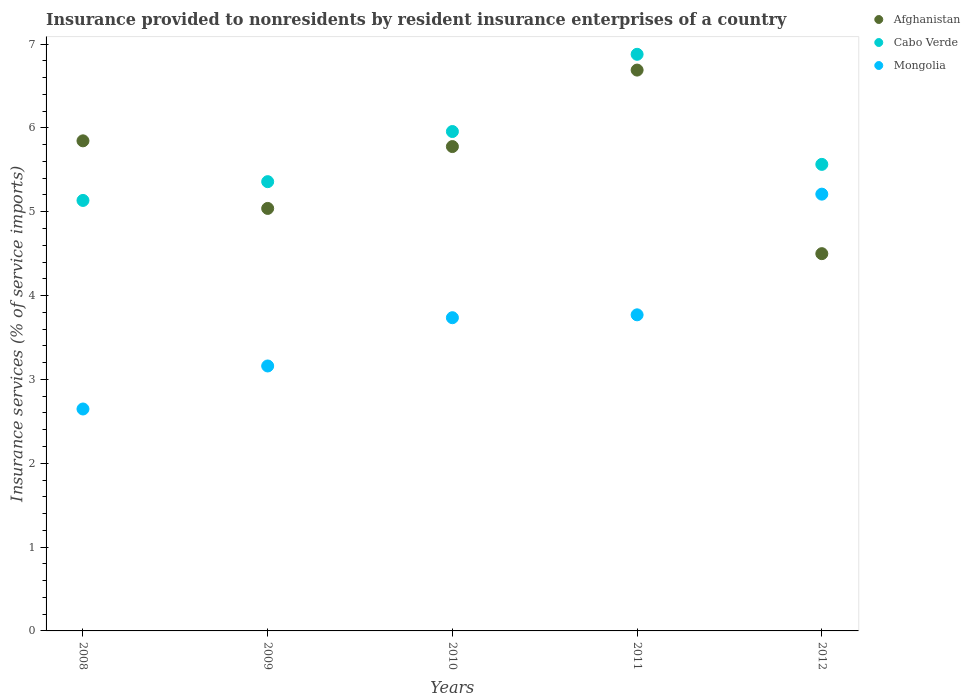What is the insurance provided to nonresidents in Afghanistan in 2010?
Provide a succinct answer. 5.78. Across all years, what is the maximum insurance provided to nonresidents in Afghanistan?
Ensure brevity in your answer.  6.69. Across all years, what is the minimum insurance provided to nonresidents in Mongolia?
Make the answer very short. 2.65. In which year was the insurance provided to nonresidents in Cabo Verde minimum?
Make the answer very short. 2008. What is the total insurance provided to nonresidents in Mongolia in the graph?
Keep it short and to the point. 18.52. What is the difference between the insurance provided to nonresidents in Cabo Verde in 2009 and that in 2012?
Provide a succinct answer. -0.21. What is the difference between the insurance provided to nonresidents in Afghanistan in 2011 and the insurance provided to nonresidents in Mongolia in 2009?
Ensure brevity in your answer.  3.53. What is the average insurance provided to nonresidents in Afghanistan per year?
Your answer should be compact. 5.57. In the year 2011, what is the difference between the insurance provided to nonresidents in Afghanistan and insurance provided to nonresidents in Mongolia?
Keep it short and to the point. 2.92. What is the ratio of the insurance provided to nonresidents in Cabo Verde in 2009 to that in 2010?
Provide a short and direct response. 0.9. Is the difference between the insurance provided to nonresidents in Afghanistan in 2009 and 2012 greater than the difference between the insurance provided to nonresidents in Mongolia in 2009 and 2012?
Offer a terse response. Yes. What is the difference between the highest and the second highest insurance provided to nonresidents in Mongolia?
Your answer should be very brief. 1.44. What is the difference between the highest and the lowest insurance provided to nonresidents in Mongolia?
Offer a terse response. 2.56. In how many years, is the insurance provided to nonresidents in Mongolia greater than the average insurance provided to nonresidents in Mongolia taken over all years?
Your answer should be very brief. 3. Is the sum of the insurance provided to nonresidents in Mongolia in 2010 and 2012 greater than the maximum insurance provided to nonresidents in Afghanistan across all years?
Your answer should be compact. Yes. Is it the case that in every year, the sum of the insurance provided to nonresidents in Afghanistan and insurance provided to nonresidents in Mongolia  is greater than the insurance provided to nonresidents in Cabo Verde?
Ensure brevity in your answer.  Yes. Is the insurance provided to nonresidents in Mongolia strictly less than the insurance provided to nonresidents in Afghanistan over the years?
Your answer should be very brief. No. What is the title of the graph?
Keep it short and to the point. Insurance provided to nonresidents by resident insurance enterprises of a country. Does "Tunisia" appear as one of the legend labels in the graph?
Keep it short and to the point. No. What is the label or title of the X-axis?
Provide a short and direct response. Years. What is the label or title of the Y-axis?
Offer a very short reply. Insurance services (% of service imports). What is the Insurance services (% of service imports) of Afghanistan in 2008?
Ensure brevity in your answer.  5.85. What is the Insurance services (% of service imports) of Cabo Verde in 2008?
Keep it short and to the point. 5.13. What is the Insurance services (% of service imports) of Mongolia in 2008?
Your answer should be very brief. 2.65. What is the Insurance services (% of service imports) of Afghanistan in 2009?
Provide a short and direct response. 5.04. What is the Insurance services (% of service imports) in Cabo Verde in 2009?
Keep it short and to the point. 5.36. What is the Insurance services (% of service imports) of Mongolia in 2009?
Offer a very short reply. 3.16. What is the Insurance services (% of service imports) of Afghanistan in 2010?
Your response must be concise. 5.78. What is the Insurance services (% of service imports) of Cabo Verde in 2010?
Your answer should be compact. 5.96. What is the Insurance services (% of service imports) of Mongolia in 2010?
Your answer should be very brief. 3.74. What is the Insurance services (% of service imports) of Afghanistan in 2011?
Your answer should be very brief. 6.69. What is the Insurance services (% of service imports) in Cabo Verde in 2011?
Provide a succinct answer. 6.88. What is the Insurance services (% of service imports) of Mongolia in 2011?
Offer a very short reply. 3.77. What is the Insurance services (% of service imports) of Afghanistan in 2012?
Your response must be concise. 4.5. What is the Insurance services (% of service imports) of Cabo Verde in 2012?
Offer a terse response. 5.56. What is the Insurance services (% of service imports) in Mongolia in 2012?
Make the answer very short. 5.21. Across all years, what is the maximum Insurance services (% of service imports) of Afghanistan?
Your answer should be very brief. 6.69. Across all years, what is the maximum Insurance services (% of service imports) in Cabo Verde?
Keep it short and to the point. 6.88. Across all years, what is the maximum Insurance services (% of service imports) in Mongolia?
Your answer should be compact. 5.21. Across all years, what is the minimum Insurance services (% of service imports) in Afghanistan?
Ensure brevity in your answer.  4.5. Across all years, what is the minimum Insurance services (% of service imports) of Cabo Verde?
Provide a succinct answer. 5.13. Across all years, what is the minimum Insurance services (% of service imports) of Mongolia?
Keep it short and to the point. 2.65. What is the total Insurance services (% of service imports) of Afghanistan in the graph?
Offer a very short reply. 27.85. What is the total Insurance services (% of service imports) in Cabo Verde in the graph?
Your answer should be very brief. 28.89. What is the total Insurance services (% of service imports) in Mongolia in the graph?
Provide a succinct answer. 18.52. What is the difference between the Insurance services (% of service imports) in Afghanistan in 2008 and that in 2009?
Your answer should be very brief. 0.81. What is the difference between the Insurance services (% of service imports) in Cabo Verde in 2008 and that in 2009?
Offer a terse response. -0.22. What is the difference between the Insurance services (% of service imports) of Mongolia in 2008 and that in 2009?
Your answer should be very brief. -0.51. What is the difference between the Insurance services (% of service imports) of Afghanistan in 2008 and that in 2010?
Give a very brief answer. 0.07. What is the difference between the Insurance services (% of service imports) in Cabo Verde in 2008 and that in 2010?
Ensure brevity in your answer.  -0.82. What is the difference between the Insurance services (% of service imports) of Mongolia in 2008 and that in 2010?
Keep it short and to the point. -1.09. What is the difference between the Insurance services (% of service imports) of Afghanistan in 2008 and that in 2011?
Your answer should be compact. -0.84. What is the difference between the Insurance services (% of service imports) of Cabo Verde in 2008 and that in 2011?
Your answer should be compact. -1.74. What is the difference between the Insurance services (% of service imports) of Mongolia in 2008 and that in 2011?
Ensure brevity in your answer.  -1.12. What is the difference between the Insurance services (% of service imports) in Afghanistan in 2008 and that in 2012?
Offer a terse response. 1.35. What is the difference between the Insurance services (% of service imports) of Cabo Verde in 2008 and that in 2012?
Make the answer very short. -0.43. What is the difference between the Insurance services (% of service imports) in Mongolia in 2008 and that in 2012?
Your answer should be compact. -2.56. What is the difference between the Insurance services (% of service imports) in Afghanistan in 2009 and that in 2010?
Give a very brief answer. -0.74. What is the difference between the Insurance services (% of service imports) of Cabo Verde in 2009 and that in 2010?
Offer a terse response. -0.6. What is the difference between the Insurance services (% of service imports) of Mongolia in 2009 and that in 2010?
Offer a very short reply. -0.58. What is the difference between the Insurance services (% of service imports) of Afghanistan in 2009 and that in 2011?
Your answer should be compact. -1.65. What is the difference between the Insurance services (% of service imports) in Cabo Verde in 2009 and that in 2011?
Your answer should be compact. -1.52. What is the difference between the Insurance services (% of service imports) in Mongolia in 2009 and that in 2011?
Offer a terse response. -0.61. What is the difference between the Insurance services (% of service imports) of Afghanistan in 2009 and that in 2012?
Provide a short and direct response. 0.54. What is the difference between the Insurance services (% of service imports) of Cabo Verde in 2009 and that in 2012?
Offer a very short reply. -0.21. What is the difference between the Insurance services (% of service imports) of Mongolia in 2009 and that in 2012?
Offer a terse response. -2.05. What is the difference between the Insurance services (% of service imports) of Afghanistan in 2010 and that in 2011?
Offer a terse response. -0.91. What is the difference between the Insurance services (% of service imports) of Cabo Verde in 2010 and that in 2011?
Give a very brief answer. -0.92. What is the difference between the Insurance services (% of service imports) in Mongolia in 2010 and that in 2011?
Provide a succinct answer. -0.03. What is the difference between the Insurance services (% of service imports) in Afghanistan in 2010 and that in 2012?
Make the answer very short. 1.28. What is the difference between the Insurance services (% of service imports) in Cabo Verde in 2010 and that in 2012?
Make the answer very short. 0.39. What is the difference between the Insurance services (% of service imports) of Mongolia in 2010 and that in 2012?
Your response must be concise. -1.47. What is the difference between the Insurance services (% of service imports) in Afghanistan in 2011 and that in 2012?
Provide a succinct answer. 2.19. What is the difference between the Insurance services (% of service imports) of Cabo Verde in 2011 and that in 2012?
Your response must be concise. 1.31. What is the difference between the Insurance services (% of service imports) in Mongolia in 2011 and that in 2012?
Make the answer very short. -1.44. What is the difference between the Insurance services (% of service imports) of Afghanistan in 2008 and the Insurance services (% of service imports) of Cabo Verde in 2009?
Offer a very short reply. 0.49. What is the difference between the Insurance services (% of service imports) in Afghanistan in 2008 and the Insurance services (% of service imports) in Mongolia in 2009?
Your response must be concise. 2.69. What is the difference between the Insurance services (% of service imports) of Cabo Verde in 2008 and the Insurance services (% of service imports) of Mongolia in 2009?
Provide a succinct answer. 1.97. What is the difference between the Insurance services (% of service imports) in Afghanistan in 2008 and the Insurance services (% of service imports) in Cabo Verde in 2010?
Make the answer very short. -0.11. What is the difference between the Insurance services (% of service imports) in Afghanistan in 2008 and the Insurance services (% of service imports) in Mongolia in 2010?
Your answer should be compact. 2.11. What is the difference between the Insurance services (% of service imports) of Cabo Verde in 2008 and the Insurance services (% of service imports) of Mongolia in 2010?
Your answer should be very brief. 1.4. What is the difference between the Insurance services (% of service imports) of Afghanistan in 2008 and the Insurance services (% of service imports) of Cabo Verde in 2011?
Keep it short and to the point. -1.03. What is the difference between the Insurance services (% of service imports) of Afghanistan in 2008 and the Insurance services (% of service imports) of Mongolia in 2011?
Your answer should be very brief. 2.08. What is the difference between the Insurance services (% of service imports) of Cabo Verde in 2008 and the Insurance services (% of service imports) of Mongolia in 2011?
Give a very brief answer. 1.36. What is the difference between the Insurance services (% of service imports) of Afghanistan in 2008 and the Insurance services (% of service imports) of Cabo Verde in 2012?
Offer a terse response. 0.28. What is the difference between the Insurance services (% of service imports) in Afghanistan in 2008 and the Insurance services (% of service imports) in Mongolia in 2012?
Offer a terse response. 0.64. What is the difference between the Insurance services (% of service imports) of Cabo Verde in 2008 and the Insurance services (% of service imports) of Mongolia in 2012?
Provide a succinct answer. -0.07. What is the difference between the Insurance services (% of service imports) in Afghanistan in 2009 and the Insurance services (% of service imports) in Cabo Verde in 2010?
Your response must be concise. -0.92. What is the difference between the Insurance services (% of service imports) of Afghanistan in 2009 and the Insurance services (% of service imports) of Mongolia in 2010?
Make the answer very short. 1.3. What is the difference between the Insurance services (% of service imports) of Cabo Verde in 2009 and the Insurance services (% of service imports) of Mongolia in 2010?
Your answer should be compact. 1.62. What is the difference between the Insurance services (% of service imports) of Afghanistan in 2009 and the Insurance services (% of service imports) of Cabo Verde in 2011?
Give a very brief answer. -1.84. What is the difference between the Insurance services (% of service imports) in Afghanistan in 2009 and the Insurance services (% of service imports) in Mongolia in 2011?
Your answer should be very brief. 1.27. What is the difference between the Insurance services (% of service imports) in Cabo Verde in 2009 and the Insurance services (% of service imports) in Mongolia in 2011?
Give a very brief answer. 1.59. What is the difference between the Insurance services (% of service imports) in Afghanistan in 2009 and the Insurance services (% of service imports) in Cabo Verde in 2012?
Provide a succinct answer. -0.53. What is the difference between the Insurance services (% of service imports) in Afghanistan in 2009 and the Insurance services (% of service imports) in Mongolia in 2012?
Your answer should be compact. -0.17. What is the difference between the Insurance services (% of service imports) in Cabo Verde in 2009 and the Insurance services (% of service imports) in Mongolia in 2012?
Your answer should be compact. 0.15. What is the difference between the Insurance services (% of service imports) of Afghanistan in 2010 and the Insurance services (% of service imports) of Cabo Verde in 2011?
Provide a short and direct response. -1.1. What is the difference between the Insurance services (% of service imports) of Afghanistan in 2010 and the Insurance services (% of service imports) of Mongolia in 2011?
Provide a short and direct response. 2.01. What is the difference between the Insurance services (% of service imports) of Cabo Verde in 2010 and the Insurance services (% of service imports) of Mongolia in 2011?
Your answer should be very brief. 2.19. What is the difference between the Insurance services (% of service imports) of Afghanistan in 2010 and the Insurance services (% of service imports) of Cabo Verde in 2012?
Give a very brief answer. 0.21. What is the difference between the Insurance services (% of service imports) of Afghanistan in 2010 and the Insurance services (% of service imports) of Mongolia in 2012?
Keep it short and to the point. 0.57. What is the difference between the Insurance services (% of service imports) in Cabo Verde in 2010 and the Insurance services (% of service imports) in Mongolia in 2012?
Your response must be concise. 0.75. What is the difference between the Insurance services (% of service imports) in Afghanistan in 2011 and the Insurance services (% of service imports) in Cabo Verde in 2012?
Make the answer very short. 1.12. What is the difference between the Insurance services (% of service imports) in Afghanistan in 2011 and the Insurance services (% of service imports) in Mongolia in 2012?
Your answer should be compact. 1.48. What is the difference between the Insurance services (% of service imports) in Cabo Verde in 2011 and the Insurance services (% of service imports) in Mongolia in 2012?
Provide a succinct answer. 1.67. What is the average Insurance services (% of service imports) in Afghanistan per year?
Your answer should be compact. 5.57. What is the average Insurance services (% of service imports) of Cabo Verde per year?
Ensure brevity in your answer.  5.78. What is the average Insurance services (% of service imports) of Mongolia per year?
Provide a short and direct response. 3.7. In the year 2008, what is the difference between the Insurance services (% of service imports) in Afghanistan and Insurance services (% of service imports) in Cabo Verde?
Offer a terse response. 0.71. In the year 2008, what is the difference between the Insurance services (% of service imports) in Afghanistan and Insurance services (% of service imports) in Mongolia?
Your answer should be very brief. 3.2. In the year 2008, what is the difference between the Insurance services (% of service imports) in Cabo Verde and Insurance services (% of service imports) in Mongolia?
Offer a terse response. 2.49. In the year 2009, what is the difference between the Insurance services (% of service imports) in Afghanistan and Insurance services (% of service imports) in Cabo Verde?
Ensure brevity in your answer.  -0.32. In the year 2009, what is the difference between the Insurance services (% of service imports) in Afghanistan and Insurance services (% of service imports) in Mongolia?
Offer a very short reply. 1.88. In the year 2009, what is the difference between the Insurance services (% of service imports) of Cabo Verde and Insurance services (% of service imports) of Mongolia?
Your response must be concise. 2.2. In the year 2010, what is the difference between the Insurance services (% of service imports) of Afghanistan and Insurance services (% of service imports) of Cabo Verde?
Provide a short and direct response. -0.18. In the year 2010, what is the difference between the Insurance services (% of service imports) of Afghanistan and Insurance services (% of service imports) of Mongolia?
Make the answer very short. 2.04. In the year 2010, what is the difference between the Insurance services (% of service imports) of Cabo Verde and Insurance services (% of service imports) of Mongolia?
Your answer should be very brief. 2.22. In the year 2011, what is the difference between the Insurance services (% of service imports) of Afghanistan and Insurance services (% of service imports) of Cabo Verde?
Your answer should be compact. -0.19. In the year 2011, what is the difference between the Insurance services (% of service imports) of Afghanistan and Insurance services (% of service imports) of Mongolia?
Give a very brief answer. 2.92. In the year 2011, what is the difference between the Insurance services (% of service imports) in Cabo Verde and Insurance services (% of service imports) in Mongolia?
Your answer should be compact. 3.11. In the year 2012, what is the difference between the Insurance services (% of service imports) in Afghanistan and Insurance services (% of service imports) in Cabo Verde?
Provide a short and direct response. -1.06. In the year 2012, what is the difference between the Insurance services (% of service imports) in Afghanistan and Insurance services (% of service imports) in Mongolia?
Your answer should be very brief. -0.71. In the year 2012, what is the difference between the Insurance services (% of service imports) in Cabo Verde and Insurance services (% of service imports) in Mongolia?
Offer a very short reply. 0.36. What is the ratio of the Insurance services (% of service imports) in Afghanistan in 2008 to that in 2009?
Provide a short and direct response. 1.16. What is the ratio of the Insurance services (% of service imports) of Cabo Verde in 2008 to that in 2009?
Your answer should be compact. 0.96. What is the ratio of the Insurance services (% of service imports) of Mongolia in 2008 to that in 2009?
Your answer should be very brief. 0.84. What is the ratio of the Insurance services (% of service imports) of Afghanistan in 2008 to that in 2010?
Provide a succinct answer. 1.01. What is the ratio of the Insurance services (% of service imports) of Cabo Verde in 2008 to that in 2010?
Offer a very short reply. 0.86. What is the ratio of the Insurance services (% of service imports) in Mongolia in 2008 to that in 2010?
Offer a terse response. 0.71. What is the ratio of the Insurance services (% of service imports) in Afghanistan in 2008 to that in 2011?
Offer a terse response. 0.87. What is the ratio of the Insurance services (% of service imports) in Cabo Verde in 2008 to that in 2011?
Offer a terse response. 0.75. What is the ratio of the Insurance services (% of service imports) of Mongolia in 2008 to that in 2011?
Give a very brief answer. 0.7. What is the ratio of the Insurance services (% of service imports) in Afghanistan in 2008 to that in 2012?
Provide a short and direct response. 1.3. What is the ratio of the Insurance services (% of service imports) in Cabo Verde in 2008 to that in 2012?
Offer a terse response. 0.92. What is the ratio of the Insurance services (% of service imports) of Mongolia in 2008 to that in 2012?
Offer a very short reply. 0.51. What is the ratio of the Insurance services (% of service imports) of Afghanistan in 2009 to that in 2010?
Your response must be concise. 0.87. What is the ratio of the Insurance services (% of service imports) in Cabo Verde in 2009 to that in 2010?
Your response must be concise. 0.9. What is the ratio of the Insurance services (% of service imports) in Mongolia in 2009 to that in 2010?
Provide a succinct answer. 0.85. What is the ratio of the Insurance services (% of service imports) of Afghanistan in 2009 to that in 2011?
Your answer should be compact. 0.75. What is the ratio of the Insurance services (% of service imports) of Cabo Verde in 2009 to that in 2011?
Provide a short and direct response. 0.78. What is the ratio of the Insurance services (% of service imports) in Mongolia in 2009 to that in 2011?
Your response must be concise. 0.84. What is the ratio of the Insurance services (% of service imports) in Afghanistan in 2009 to that in 2012?
Make the answer very short. 1.12. What is the ratio of the Insurance services (% of service imports) in Cabo Verde in 2009 to that in 2012?
Provide a short and direct response. 0.96. What is the ratio of the Insurance services (% of service imports) of Mongolia in 2009 to that in 2012?
Give a very brief answer. 0.61. What is the ratio of the Insurance services (% of service imports) of Afghanistan in 2010 to that in 2011?
Your answer should be very brief. 0.86. What is the ratio of the Insurance services (% of service imports) of Cabo Verde in 2010 to that in 2011?
Give a very brief answer. 0.87. What is the ratio of the Insurance services (% of service imports) in Mongolia in 2010 to that in 2011?
Offer a very short reply. 0.99. What is the ratio of the Insurance services (% of service imports) in Afghanistan in 2010 to that in 2012?
Make the answer very short. 1.28. What is the ratio of the Insurance services (% of service imports) of Cabo Verde in 2010 to that in 2012?
Provide a short and direct response. 1.07. What is the ratio of the Insurance services (% of service imports) in Mongolia in 2010 to that in 2012?
Your answer should be very brief. 0.72. What is the ratio of the Insurance services (% of service imports) in Afghanistan in 2011 to that in 2012?
Provide a short and direct response. 1.49. What is the ratio of the Insurance services (% of service imports) in Cabo Verde in 2011 to that in 2012?
Keep it short and to the point. 1.24. What is the ratio of the Insurance services (% of service imports) in Mongolia in 2011 to that in 2012?
Your answer should be very brief. 0.72. What is the difference between the highest and the second highest Insurance services (% of service imports) in Afghanistan?
Offer a terse response. 0.84. What is the difference between the highest and the second highest Insurance services (% of service imports) in Cabo Verde?
Give a very brief answer. 0.92. What is the difference between the highest and the second highest Insurance services (% of service imports) in Mongolia?
Your answer should be compact. 1.44. What is the difference between the highest and the lowest Insurance services (% of service imports) of Afghanistan?
Offer a very short reply. 2.19. What is the difference between the highest and the lowest Insurance services (% of service imports) of Cabo Verde?
Provide a short and direct response. 1.74. What is the difference between the highest and the lowest Insurance services (% of service imports) in Mongolia?
Offer a very short reply. 2.56. 